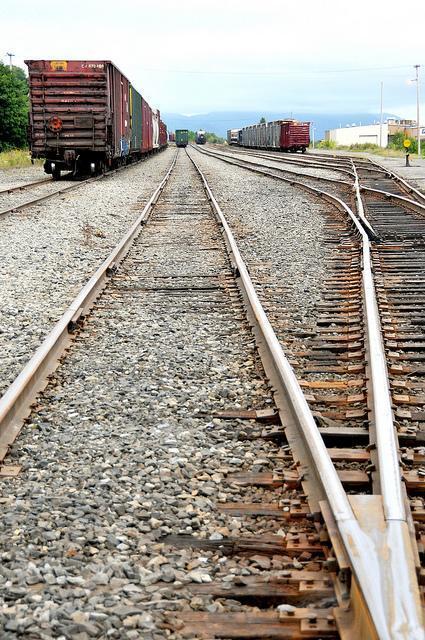How many trains are visible?
Give a very brief answer. 2. 